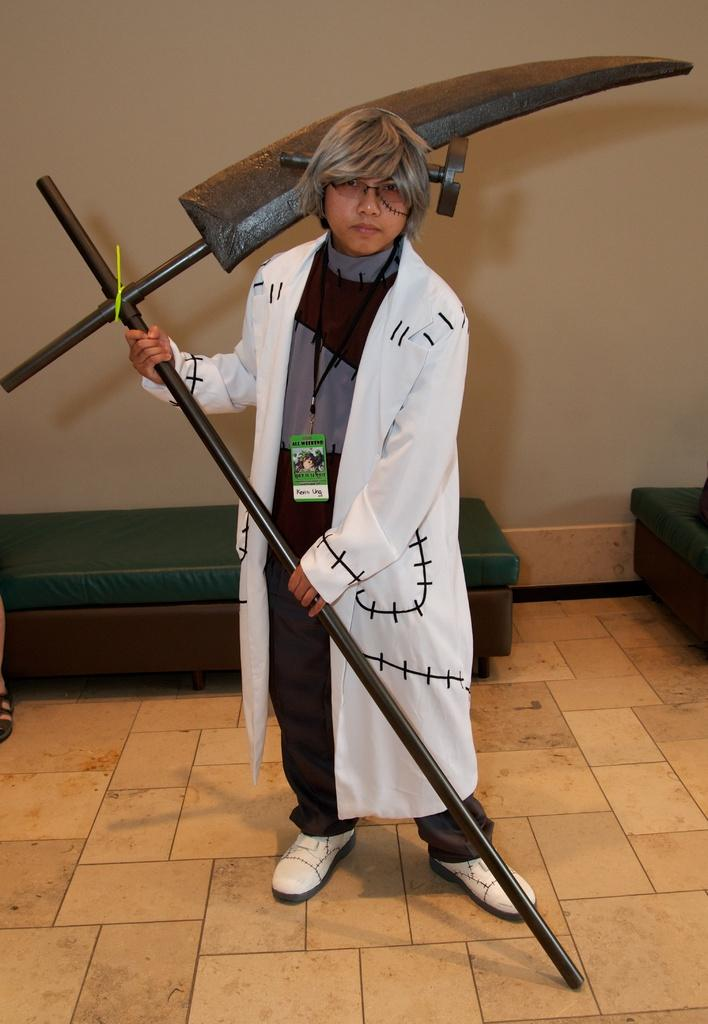What is the main subject of the image? There is a person standing in the middle of the image. What is the person holding in his hand? The person is holding a weapon in his hand. What can be seen behind the person? There are tables behind the person. What is visible at the top of the image? There is a wall visible at the top of the image. What type of boot is the person wearing in the image? There is no information about the person's footwear in the image, so we cannot determine if they are wearing a boot or any other type of shoe. What kind of drug is the person using in the image? There is no indication of drug use in the image; the person is holding a weapon. 